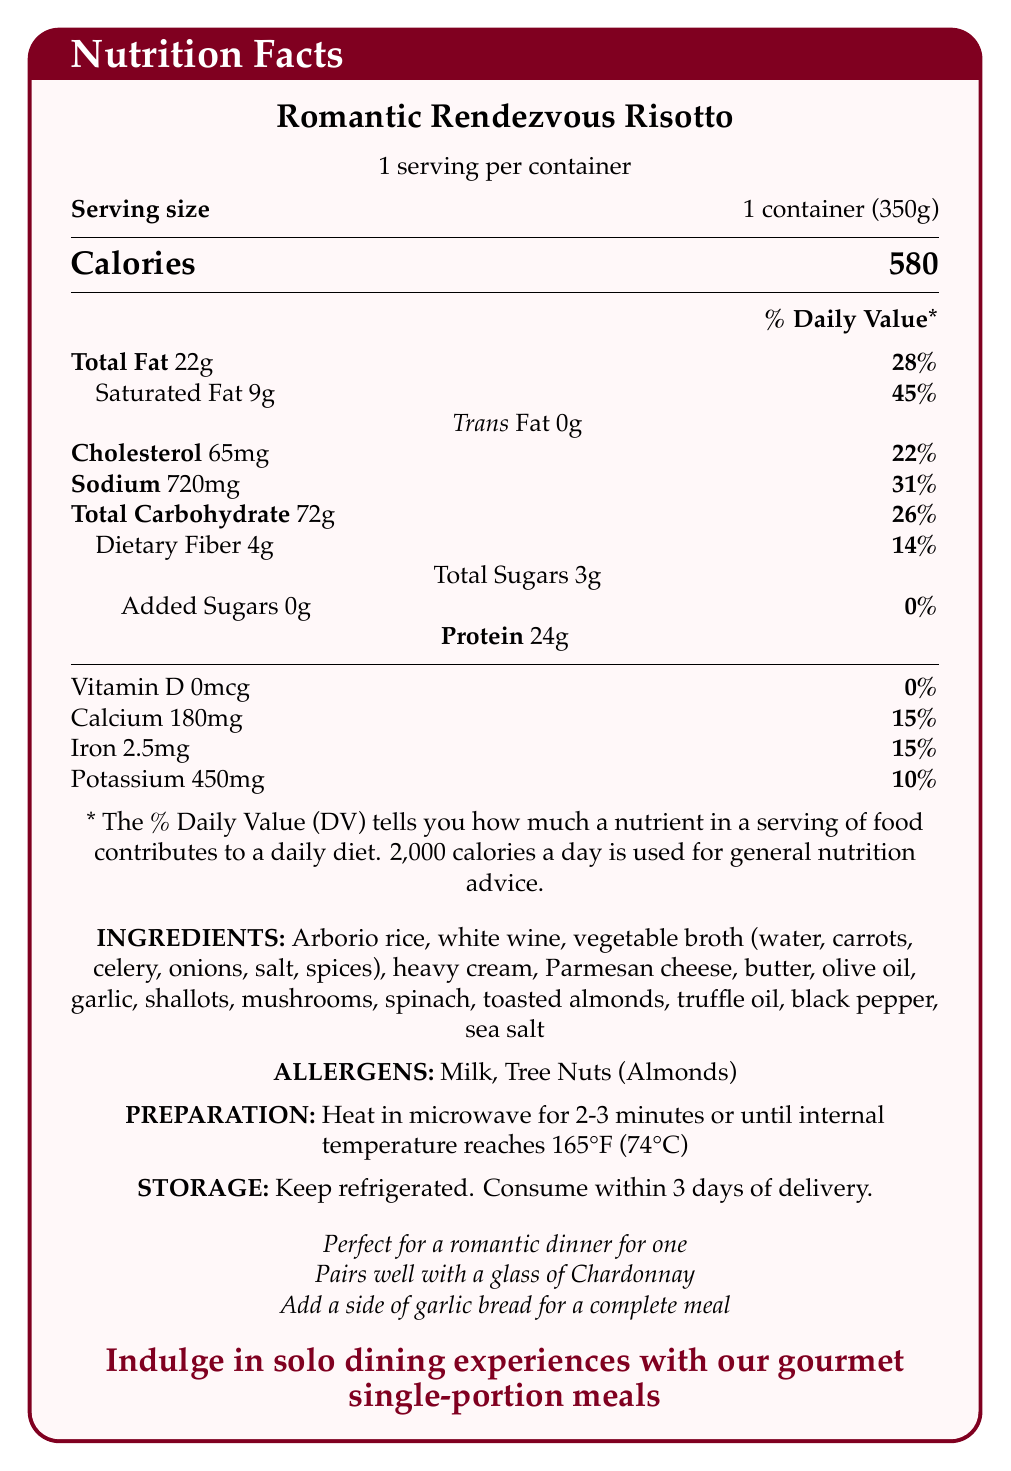what is the product name? The product name is clearly stated at the beginning of the document as "Romantic Rendezvous Risotto".
Answer: Romantic Rendezvous Risotto how many servings per container? It is mentioned in the document that there is 1 serving per container.
Answer: 1 what is the serving size? The document specifies the serving size as 1 container (350g).
Answer: 1 container (350g) how many calories are in one serving? The document shows that each serving contains 580 calories.
Answer: 580 what are the allergens listed for this product? The allergens are listed in the "ALLERGENS" section of the document as "Milk" and "Tree Nuts (Almonds)".
Answer: Milk, Tree Nuts (Almonds) how much total fat does one serving contain? The document states that there are 22g of total fat per serving.
Answer: 22g what percentage of the daily value of saturated fat does one serving contain? According to the document, one serving contains 45% of the daily value for saturated fat.
Answer: 45% how much sodium is in one serving? The document lists the sodium content as 720 mg per serving.
Answer: 720 mg how much dietary fiber is in one serving? The dietary fiber content per serving is specified as 4g.
Answer: 4g how long should you heat the product in the microwave? The preparation instructions indicate to heat the product in the microwave for 2-3 minutes.
Answer: 2-3 minutes What is the daily value percentage for calcium in one serving? A. 10% B. 15% C. 20% D. 25% The document shows that one serving contains 15% of the daily value for calcium.
Answer: B. 15% How much protein is in one serving? A. 18g B. 20g C. 22g D. 24g The document states that there are 24g of protein per serving.
Answer: D. 24g Does the product contain added sugars? The document specifies that there are 0g (0%) of added sugars in the product.
Answer: No is the product vegetarian? The document lists "Vegetarian" under dietary labels, indicating that the product is vegetarian.
Answer: Yes Summarize the nutrition and preparation details of the "Romantic Rendezvous Risotto". The summary covers the main nutritional facts, preparation process, and allergen information provided in the document.
Answer: The "Romantic Rendezvous Risotto" is a single-serving vegetarian meal with 580 calories per 350g container. It contains 22g of total fat, 9g of saturated fat, 65mg of cholesterol, 720mg of sodium, 72g of total carbohydrates, 4g of dietary fiber, 3g of total sugars, and 24g of protein. The meal should be heated in the microwave for 2-3 minutes and consumed within 3 days of delivery while being kept refrigerated. It contains allergens such as milk and tree nuts (almonds). What is the company tagline? The document features the company tagline at the bottom, highlighted in a different color.
Answer: Indulge in solo dining experiences with our gourmet single-portion meals How much potassium is in one serving? The potassium content per serving is listed as 450 mg in the document.
Answer: 450 mg How many ingredients are listed for this product? Counting the ingredients listed in the document yields a total of 17 ingredients.
Answer: 17 ingredients What type of wine pairs well with this dish according to the document? The additional information section of the document states that the dish pairs well with a glass of Chardonnay.
Answer: Chardonnay Is this product suitable for someone with tree nut allergies? The product contains almonds, which are a type of tree nut, making it unsuitable for someone with tree nut allergies.
Answer: No what is the potassium content in milligrams? According to the nutritional information, each serving contains 450 mg of potassium.
Answer: 450 mg Who is the target audience for the Romantic Rendezvous Risotto? Although the document emphasizes solo and romantic dining experiences, it does not specifically describe demographic characteristics or preferences to clearly define the target audience.
Answer: Cannot be determined 